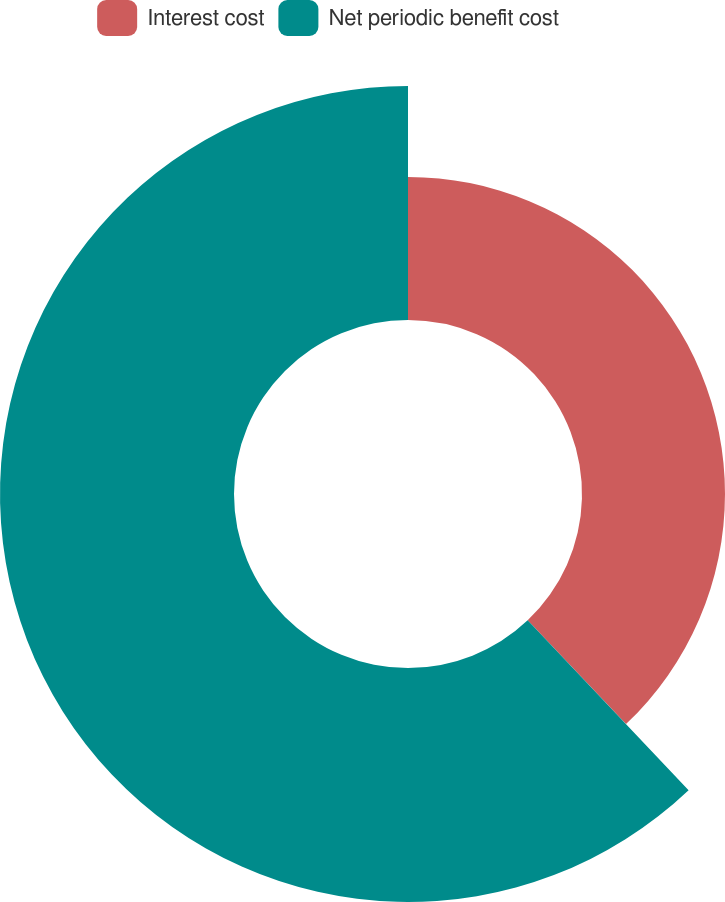<chart> <loc_0><loc_0><loc_500><loc_500><pie_chart><fcel>Interest cost<fcel>Net periodic benefit cost<nl><fcel>37.93%<fcel>62.07%<nl></chart> 